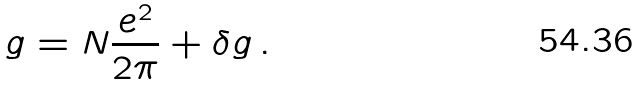<formula> <loc_0><loc_0><loc_500><loc_500>g = N \frac { e ^ { 2 } } { 2 \pi } + \delta g \, .</formula> 